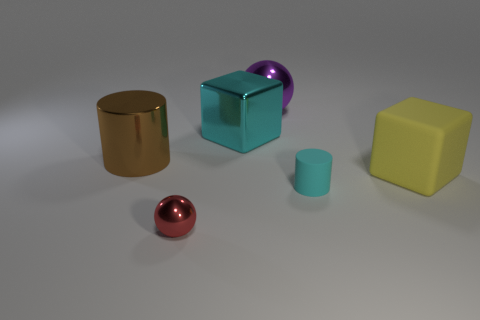There is a cyan thing that is behind the tiny cylinder that is to the right of the brown metal thing; what is it made of?
Your response must be concise. Metal. There is a block that is to the left of the small matte thing; is it the same size as the cylinder that is left of the cyan block?
Ensure brevity in your answer.  Yes. Is there any other thing that is made of the same material as the yellow cube?
Keep it short and to the point. Yes. How many big objects are red metallic spheres or rubber cylinders?
Keep it short and to the point. 0. How many things are shiny balls behind the big rubber block or large blue metal spheres?
Your answer should be compact. 1. Does the metal cylinder have the same color as the small sphere?
Ensure brevity in your answer.  No. What number of purple things are large cylinders or tiny objects?
Provide a short and direct response. 0. The block that is the same material as the large purple object is what color?
Ensure brevity in your answer.  Cyan. Is the cyan thing that is behind the small cylinder made of the same material as the cylinder that is right of the brown cylinder?
Provide a succinct answer. No. There is another thing that is the same color as the small matte thing; what size is it?
Your answer should be very brief. Large. 